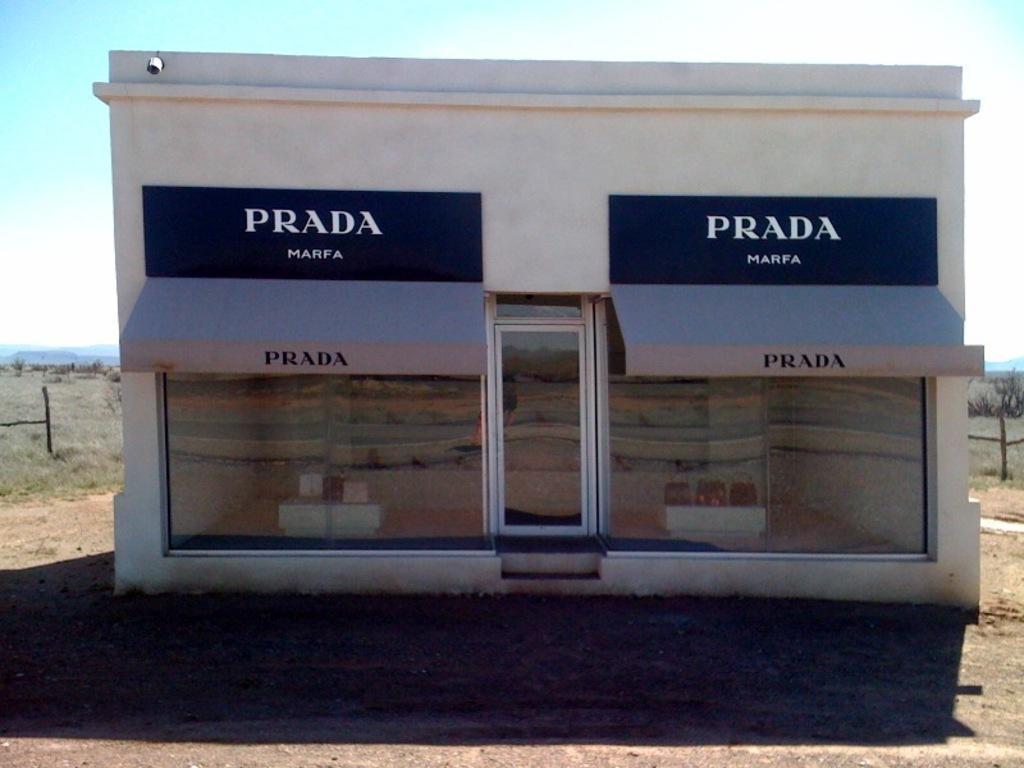Describe this image in one or two sentences. In this picture we can observe a building with glass doors. There are two blue color boards on which we can observe white color words, fixed to the wall of this building. The building is in white color. In the background there are some plants and we can observe sky. 